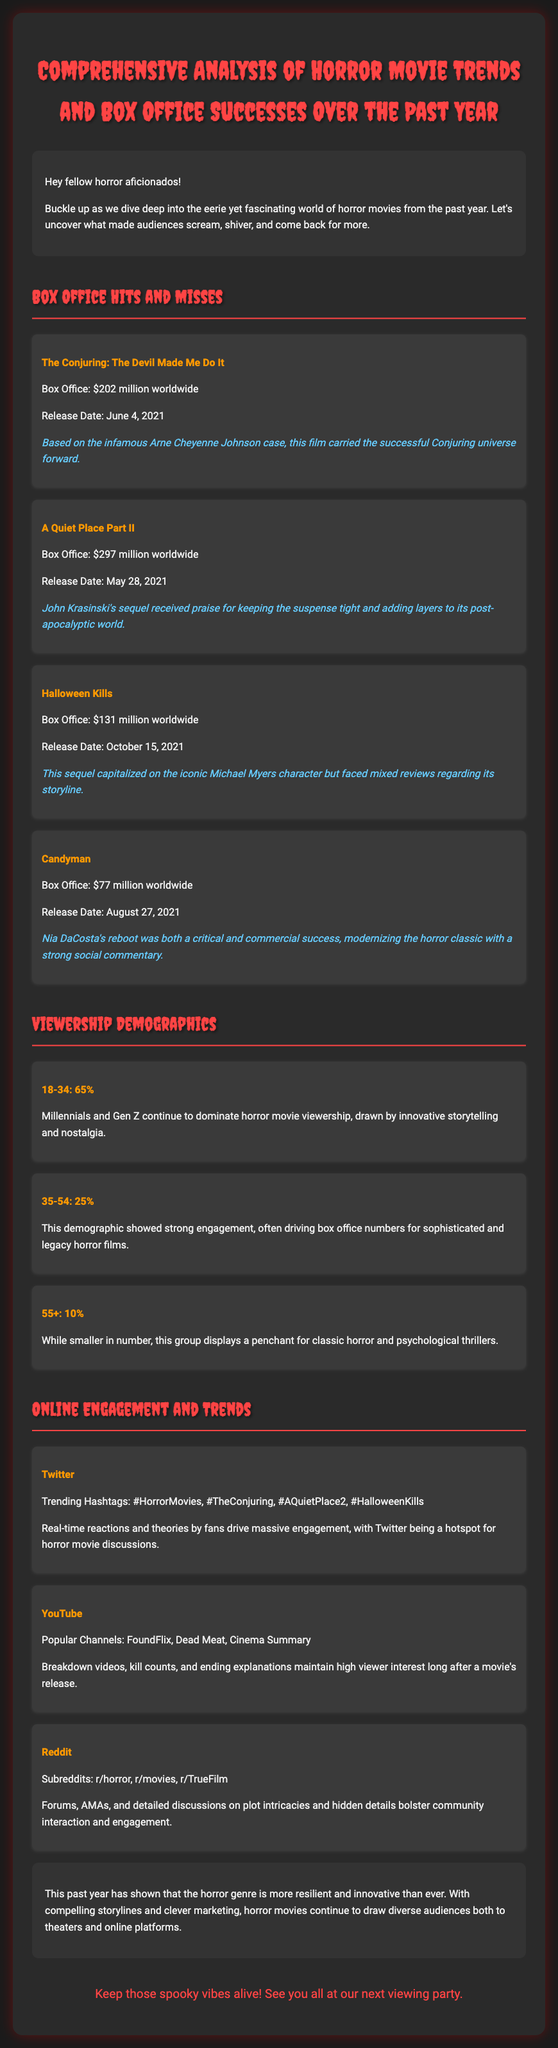What is the box office revenue for "A Quiet Place Part II"? The document states that "A Quiet Place Part II" gained $297 million worldwide.
Answer: $297 million Which demographic represents the largest percentage of horror movie viewers? The largest demographic mentioned is 18-34, accounting for 65% of viewership.
Answer: 18-34: 65% What was the release date for "Halloween Kills"? The document provides the release date for "Halloween Kills" as October 15, 2021.
Answer: October 15, 2021 What is a popular channel on YouTube for horror content? The document lists FoundFlix as a popular channel for horror content.
Answer: FoundFlix What percentage of viewers are aged 55 and older? According to the document, 10% of viewers fall into the 55 and older category.
Answer: 10% Which social media platform is highlighted for real-time reactions and theories? The document specifies that Twitter is a hotspot for horror movie discussions and reactions.
Answer: Twitter What film is based on the Arne Cheyenne Johnson case? The document indicates that "The Conjuring: The Devil Made Me Do It" is based on this case.
Answer: The Conjuring: The Devil Made Me Do It What is a trending hashtag related to horror movies? The document lists #HorrorMovies as one of the trending hashtags.
Answer: #HorrorMovies How many box office hits were listed in the document? The document mentions four movies under the box office hits section.
Answer: Four movies 